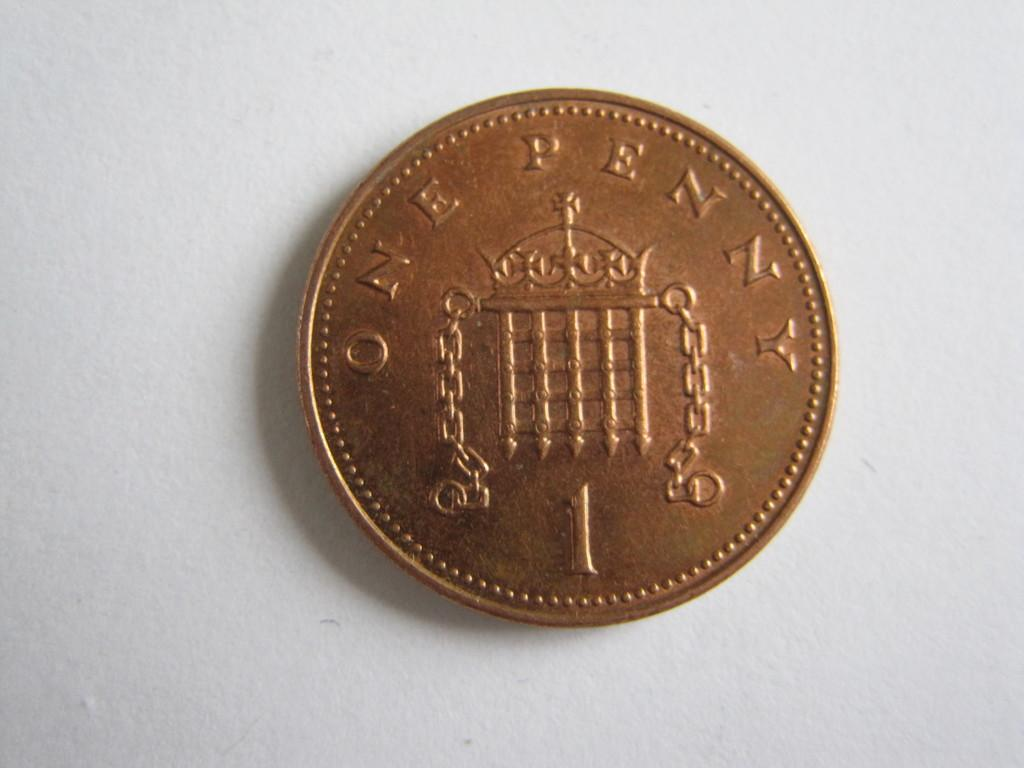<image>
Create a compact narrative representing the image presented. A cold coin that says one penny across the top of the coin. 